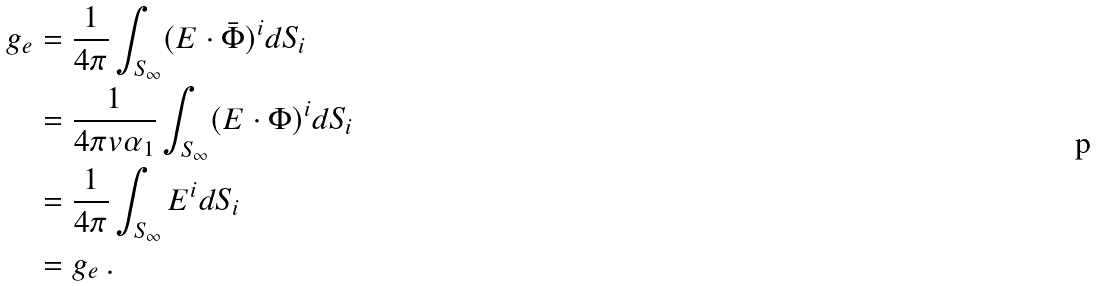Convert formula to latex. <formula><loc_0><loc_0><loc_500><loc_500>g _ { e } & = \frac { 1 } { 4 \pi } \int _ { S _ { \infty } } ( E \cdot \bar { \Phi } ) ^ { i } d S _ { i } \\ & = \frac { 1 } { 4 \pi v \alpha _ { 1 } } \int _ { S _ { \infty } } ( E \cdot \Phi ) ^ { i } d S _ { i } \\ & = \frac { 1 } { 4 \pi } \int _ { S _ { \infty } } E ^ { i } d S _ { i } \\ & = g _ { e } \, .</formula> 